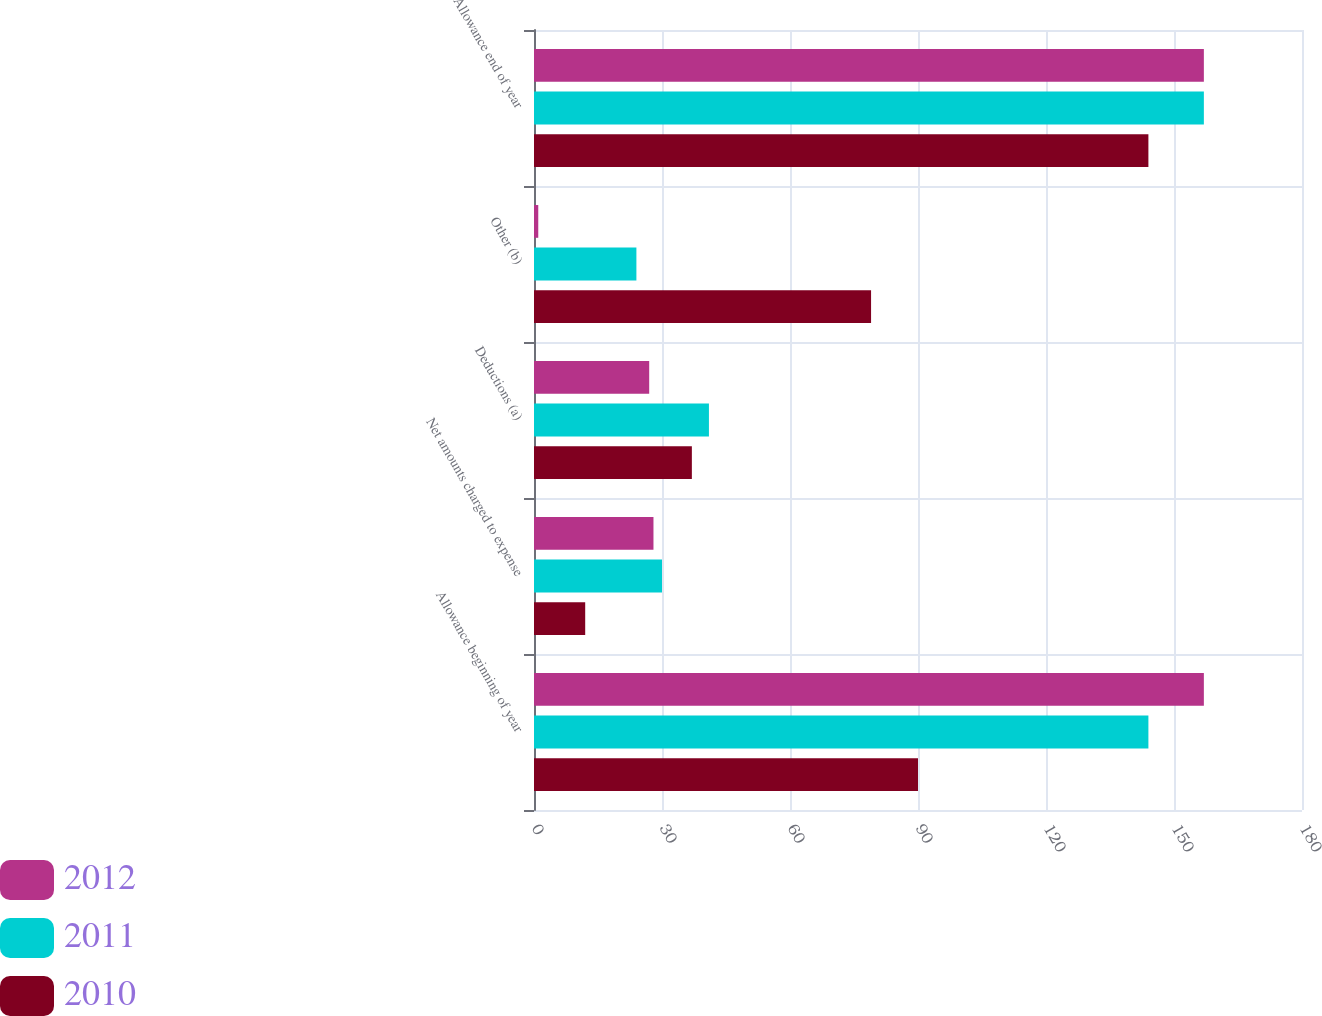<chart> <loc_0><loc_0><loc_500><loc_500><stacked_bar_chart><ecel><fcel>Allowance beginning of year<fcel>Net amounts charged to expense<fcel>Deductions (a)<fcel>Other (b)<fcel>Allowance end of year<nl><fcel>2012<fcel>157<fcel>28<fcel>27<fcel>1<fcel>157<nl><fcel>2011<fcel>144<fcel>30<fcel>41<fcel>24<fcel>157<nl><fcel>2010<fcel>90<fcel>12<fcel>37<fcel>79<fcel>144<nl></chart> 